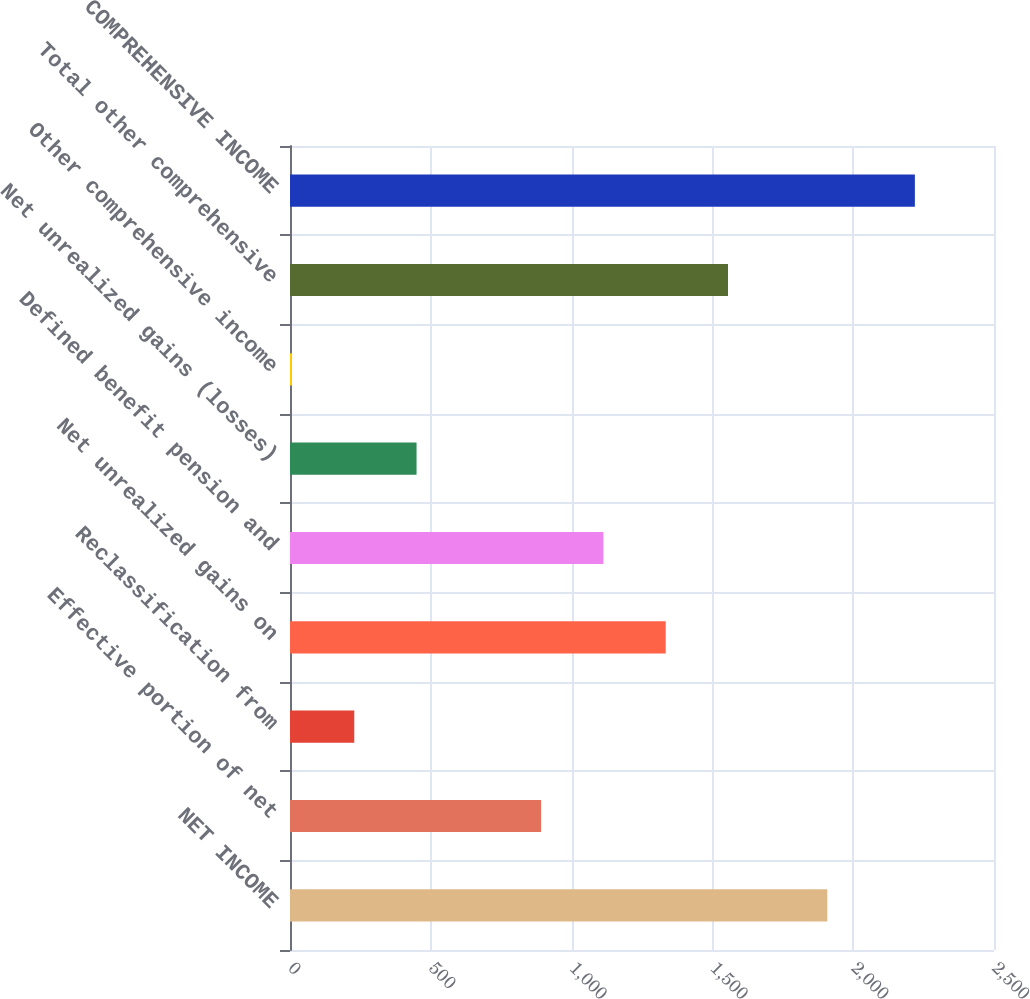Convert chart to OTSL. <chart><loc_0><loc_0><loc_500><loc_500><bar_chart><fcel>NET INCOME<fcel>Effective portion of net<fcel>Reclassification from<fcel>Net unrealized gains on<fcel>Defined benefit pension and<fcel>Net unrealized gains (losses)<fcel>Other comprehensive income<fcel>Total other comprehensive<fcel>COMPREHENSIVE INCOME<nl><fcel>1908<fcel>891.8<fcel>228.2<fcel>1334.2<fcel>1113<fcel>449.4<fcel>7<fcel>1555.4<fcel>2219<nl></chart> 